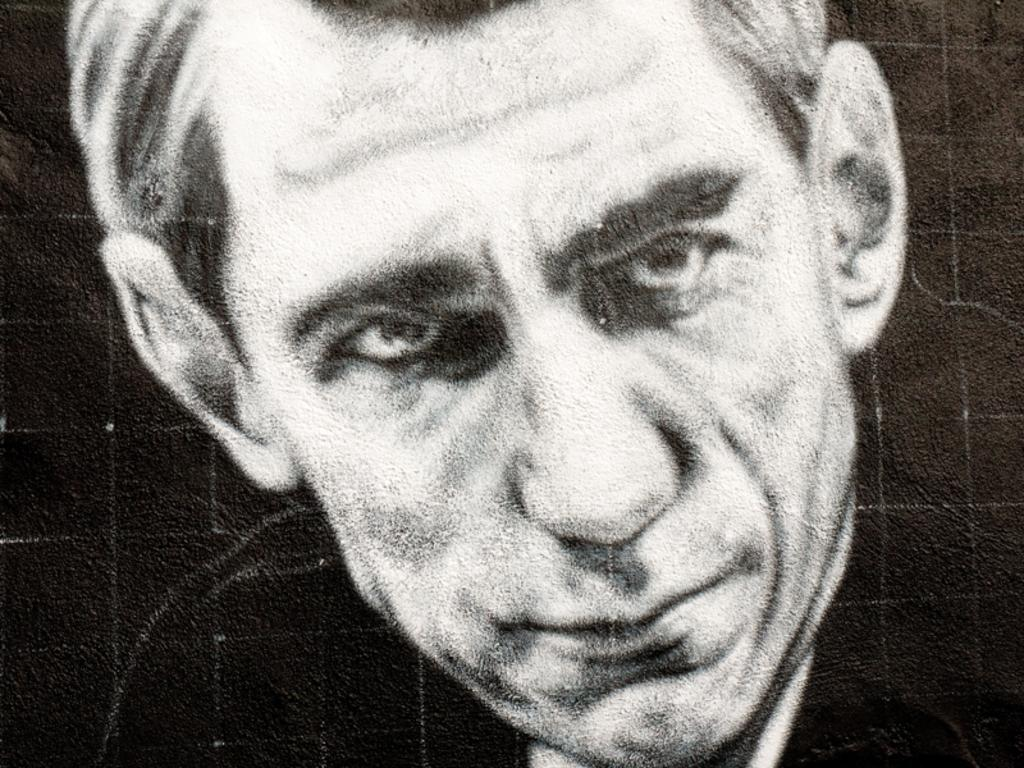What is the main subject of the image? There is a man's face in the image. Reasoning: Let' Let's think step by step in order to produce the conversation. We start by identifying the main subject of the image, which is the man's face. Since there is only one fact provided, we formulate a question that focuses on this subject, ensuring that the language is simple and clear. Absurd Question/Answer: What type of snake can be seen slithering in the background of the image? There is no snake present in the image; it only features a man's face. What time of day is it in the image, considering the presence of a sack? There is no sack present in the image, and the time of day cannot be determined from the man's face alone. What type of snake can be seen slithering in the background of the image? There is no snake present in the image; it only features a man's face. What time of day is it in the image, considering the presence of a sack? There is no sack present in the image, and the time of day cannot be determined from the man's face alone. 